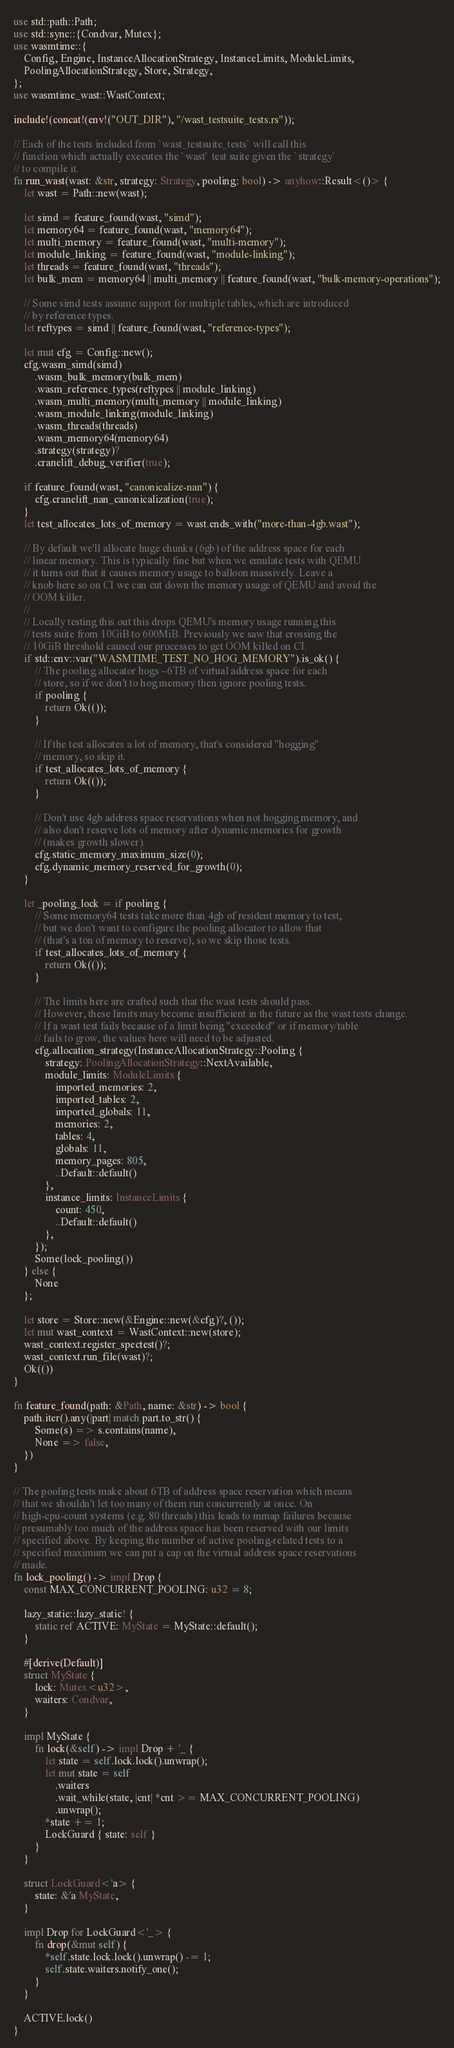<code> <loc_0><loc_0><loc_500><loc_500><_Rust_>use std::path::Path;
use std::sync::{Condvar, Mutex};
use wasmtime::{
    Config, Engine, InstanceAllocationStrategy, InstanceLimits, ModuleLimits,
    PoolingAllocationStrategy, Store, Strategy,
};
use wasmtime_wast::WastContext;

include!(concat!(env!("OUT_DIR"), "/wast_testsuite_tests.rs"));

// Each of the tests included from `wast_testsuite_tests` will call this
// function which actually executes the `wast` test suite given the `strategy`
// to compile it.
fn run_wast(wast: &str, strategy: Strategy, pooling: bool) -> anyhow::Result<()> {
    let wast = Path::new(wast);

    let simd = feature_found(wast, "simd");
    let memory64 = feature_found(wast, "memory64");
    let multi_memory = feature_found(wast, "multi-memory");
    let module_linking = feature_found(wast, "module-linking");
    let threads = feature_found(wast, "threads");
    let bulk_mem = memory64 || multi_memory || feature_found(wast, "bulk-memory-operations");

    // Some simd tests assume support for multiple tables, which are introduced
    // by reference types.
    let reftypes = simd || feature_found(wast, "reference-types");

    let mut cfg = Config::new();
    cfg.wasm_simd(simd)
        .wasm_bulk_memory(bulk_mem)
        .wasm_reference_types(reftypes || module_linking)
        .wasm_multi_memory(multi_memory || module_linking)
        .wasm_module_linking(module_linking)
        .wasm_threads(threads)
        .wasm_memory64(memory64)
        .strategy(strategy)?
        .cranelift_debug_verifier(true);

    if feature_found(wast, "canonicalize-nan") {
        cfg.cranelift_nan_canonicalization(true);
    }
    let test_allocates_lots_of_memory = wast.ends_with("more-than-4gb.wast");

    // By default we'll allocate huge chunks (6gb) of the address space for each
    // linear memory. This is typically fine but when we emulate tests with QEMU
    // it turns out that it causes memory usage to balloon massively. Leave a
    // knob here so on CI we can cut down the memory usage of QEMU and avoid the
    // OOM killer.
    //
    // Locally testing this out this drops QEMU's memory usage running this
    // tests suite from 10GiB to 600MiB. Previously we saw that crossing the
    // 10GiB threshold caused our processes to get OOM killed on CI.
    if std::env::var("WASMTIME_TEST_NO_HOG_MEMORY").is_ok() {
        // The pooling allocator hogs ~6TB of virtual address space for each
        // store, so if we don't to hog memory then ignore pooling tests.
        if pooling {
            return Ok(());
        }

        // If the test allocates a lot of memory, that's considered "hogging"
        // memory, so skip it.
        if test_allocates_lots_of_memory {
            return Ok(());
        }

        // Don't use 4gb address space reservations when not hogging memory, and
        // also don't reserve lots of memory after dynamic memories for growth
        // (makes growth slower).
        cfg.static_memory_maximum_size(0);
        cfg.dynamic_memory_reserved_for_growth(0);
    }

    let _pooling_lock = if pooling {
        // Some memory64 tests take more than 4gb of resident memory to test,
        // but we don't want to configure the pooling allocator to allow that
        // (that's a ton of memory to reserve), so we skip those tests.
        if test_allocates_lots_of_memory {
            return Ok(());
        }

        // The limits here are crafted such that the wast tests should pass.
        // However, these limits may become insufficient in the future as the wast tests change.
        // If a wast test fails because of a limit being "exceeded" or if memory/table
        // fails to grow, the values here will need to be adjusted.
        cfg.allocation_strategy(InstanceAllocationStrategy::Pooling {
            strategy: PoolingAllocationStrategy::NextAvailable,
            module_limits: ModuleLimits {
                imported_memories: 2,
                imported_tables: 2,
                imported_globals: 11,
                memories: 2,
                tables: 4,
                globals: 11,
                memory_pages: 805,
                ..Default::default()
            },
            instance_limits: InstanceLimits {
                count: 450,
                ..Default::default()
            },
        });
        Some(lock_pooling())
    } else {
        None
    };

    let store = Store::new(&Engine::new(&cfg)?, ());
    let mut wast_context = WastContext::new(store);
    wast_context.register_spectest()?;
    wast_context.run_file(wast)?;
    Ok(())
}

fn feature_found(path: &Path, name: &str) -> bool {
    path.iter().any(|part| match part.to_str() {
        Some(s) => s.contains(name),
        None => false,
    })
}

// The pooling tests make about 6TB of address space reservation which means
// that we shouldn't let too many of them run concurrently at once. On
// high-cpu-count systems (e.g. 80 threads) this leads to mmap failures because
// presumably too much of the address space has been reserved with our limits
// specified above. By keeping the number of active pooling-related tests to a
// specified maximum we can put a cap on the virtual address space reservations
// made.
fn lock_pooling() -> impl Drop {
    const MAX_CONCURRENT_POOLING: u32 = 8;

    lazy_static::lazy_static! {
        static ref ACTIVE: MyState = MyState::default();
    }

    #[derive(Default)]
    struct MyState {
        lock: Mutex<u32>,
        waiters: Condvar,
    }

    impl MyState {
        fn lock(&self) -> impl Drop + '_ {
            let state = self.lock.lock().unwrap();
            let mut state = self
                .waiters
                .wait_while(state, |cnt| *cnt >= MAX_CONCURRENT_POOLING)
                .unwrap();
            *state += 1;
            LockGuard { state: self }
        }
    }

    struct LockGuard<'a> {
        state: &'a MyState,
    }

    impl Drop for LockGuard<'_> {
        fn drop(&mut self) {
            *self.state.lock.lock().unwrap() -= 1;
            self.state.waiters.notify_one();
        }
    }

    ACTIVE.lock()
}
</code> 